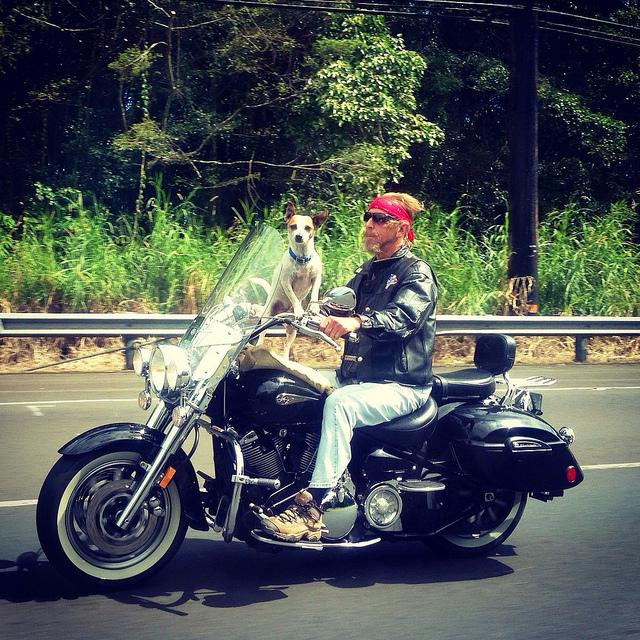What is the motorcyclist not wearing on his head that he should be?
Be succinct. Helmet. Does he have facial hair?
Answer briefly. Yes. Is that a dog on a motorcycle?
Concise answer only. Yes. 